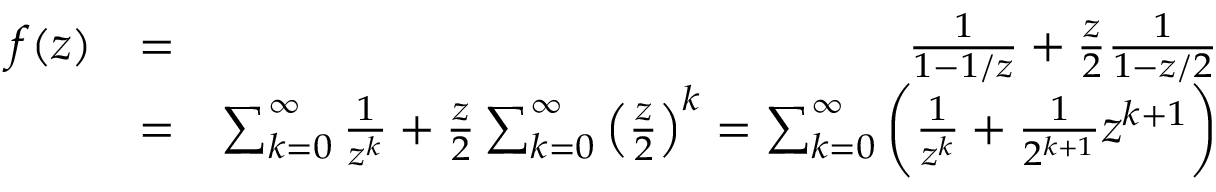Convert formula to latex. <formula><loc_0><loc_0><loc_500><loc_500>\begin{array} { r l r } { f ( z ) } & { = } & { \frac { 1 } { 1 - 1 / z } + \frac { z } { 2 } \frac { 1 } { 1 - z / 2 } } \\ & { = } & { \sum _ { k = 0 } ^ { \infty } \frac { 1 } { z ^ { k } } + \frac { z } { 2 } \sum _ { k = 0 } ^ { \infty } \left ( \frac { z } { 2 } \right ) ^ { k } = \sum _ { k = 0 } ^ { \infty } \left ( \frac { 1 } { z ^ { k } } + \frac { 1 } { 2 ^ { k + 1 } } z ^ { k + 1 } \right ) } \end{array}</formula> 